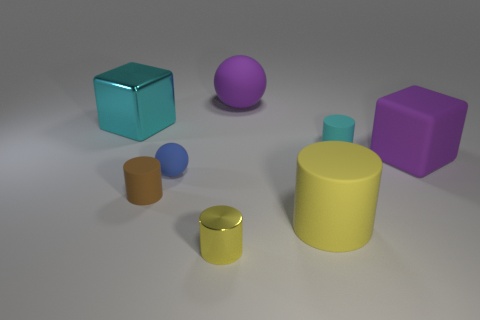Considering the lighting in the scene, where might the light source be located? The objects have shadows that extend towards the lower right of the image, implying that the light source is positioned toward the upper left side of the scene. This top-down and slightly angled lighting creates soft shadows, suggesting an environment with diffused lighting.  Are the shadows all the same length or do they vary? The shadows vary in length and size, which indicates that the objects have different heights and shapes, further informing us about their spatial arrangement and the direction of the light source. 